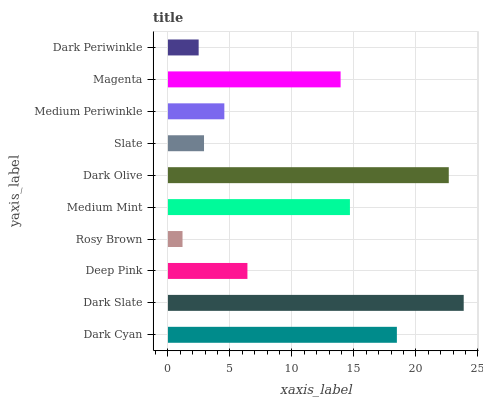Is Rosy Brown the minimum?
Answer yes or no. Yes. Is Dark Slate the maximum?
Answer yes or no. Yes. Is Deep Pink the minimum?
Answer yes or no. No. Is Deep Pink the maximum?
Answer yes or no. No. Is Dark Slate greater than Deep Pink?
Answer yes or no. Yes. Is Deep Pink less than Dark Slate?
Answer yes or no. Yes. Is Deep Pink greater than Dark Slate?
Answer yes or no. No. Is Dark Slate less than Deep Pink?
Answer yes or no. No. Is Magenta the high median?
Answer yes or no. Yes. Is Deep Pink the low median?
Answer yes or no. Yes. Is Dark Periwinkle the high median?
Answer yes or no. No. Is Dark Periwinkle the low median?
Answer yes or no. No. 